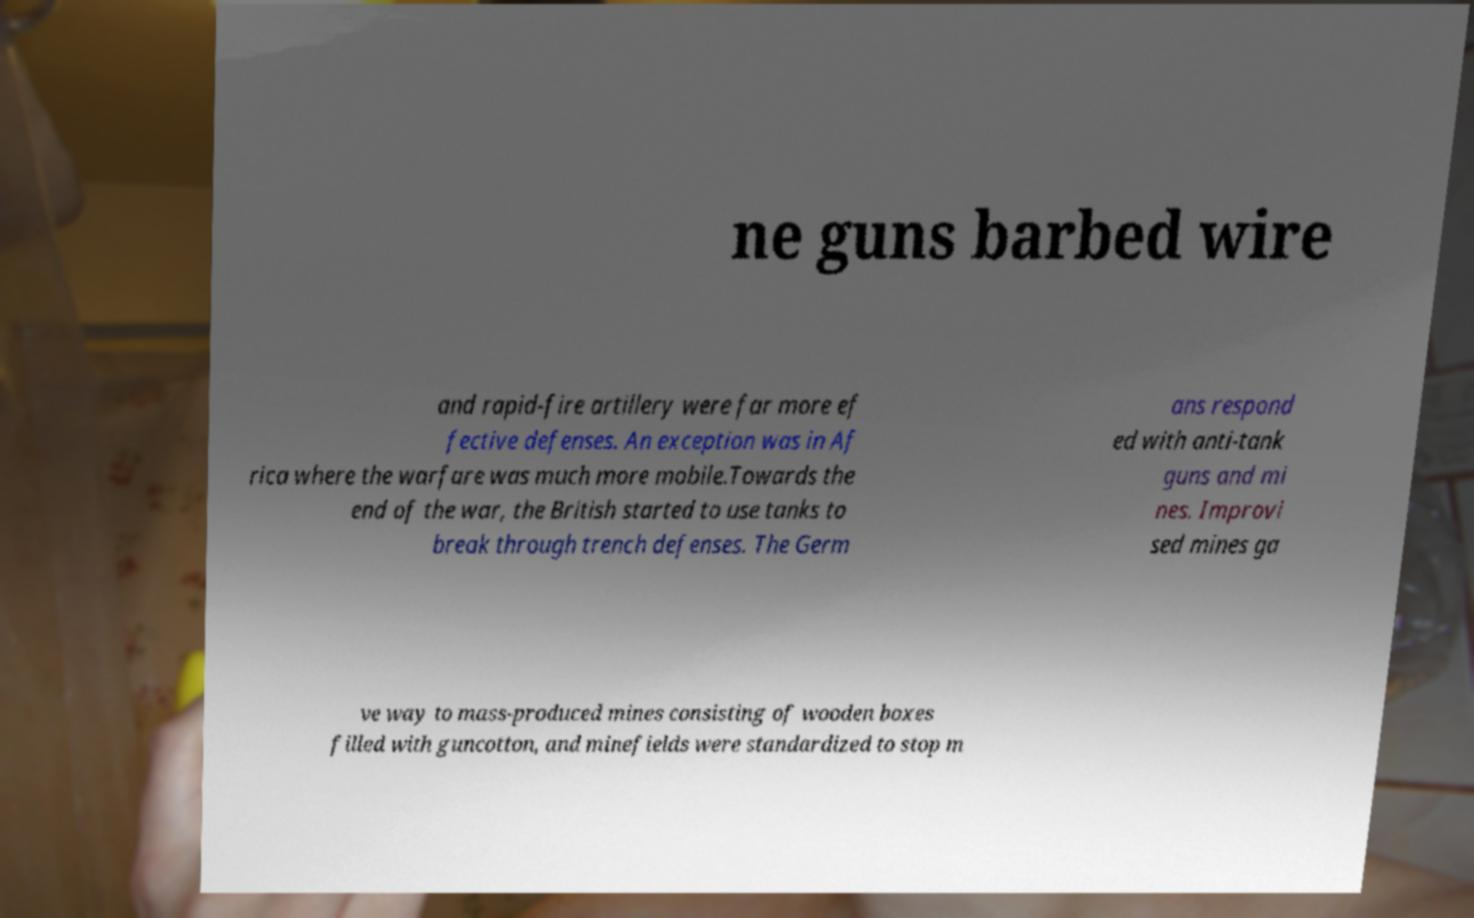Please read and relay the text visible in this image. What does it say? ne guns barbed wire and rapid-fire artillery were far more ef fective defenses. An exception was in Af rica where the warfare was much more mobile.Towards the end of the war, the British started to use tanks to break through trench defenses. The Germ ans respond ed with anti-tank guns and mi nes. Improvi sed mines ga ve way to mass-produced mines consisting of wooden boxes filled with guncotton, and minefields were standardized to stop m 